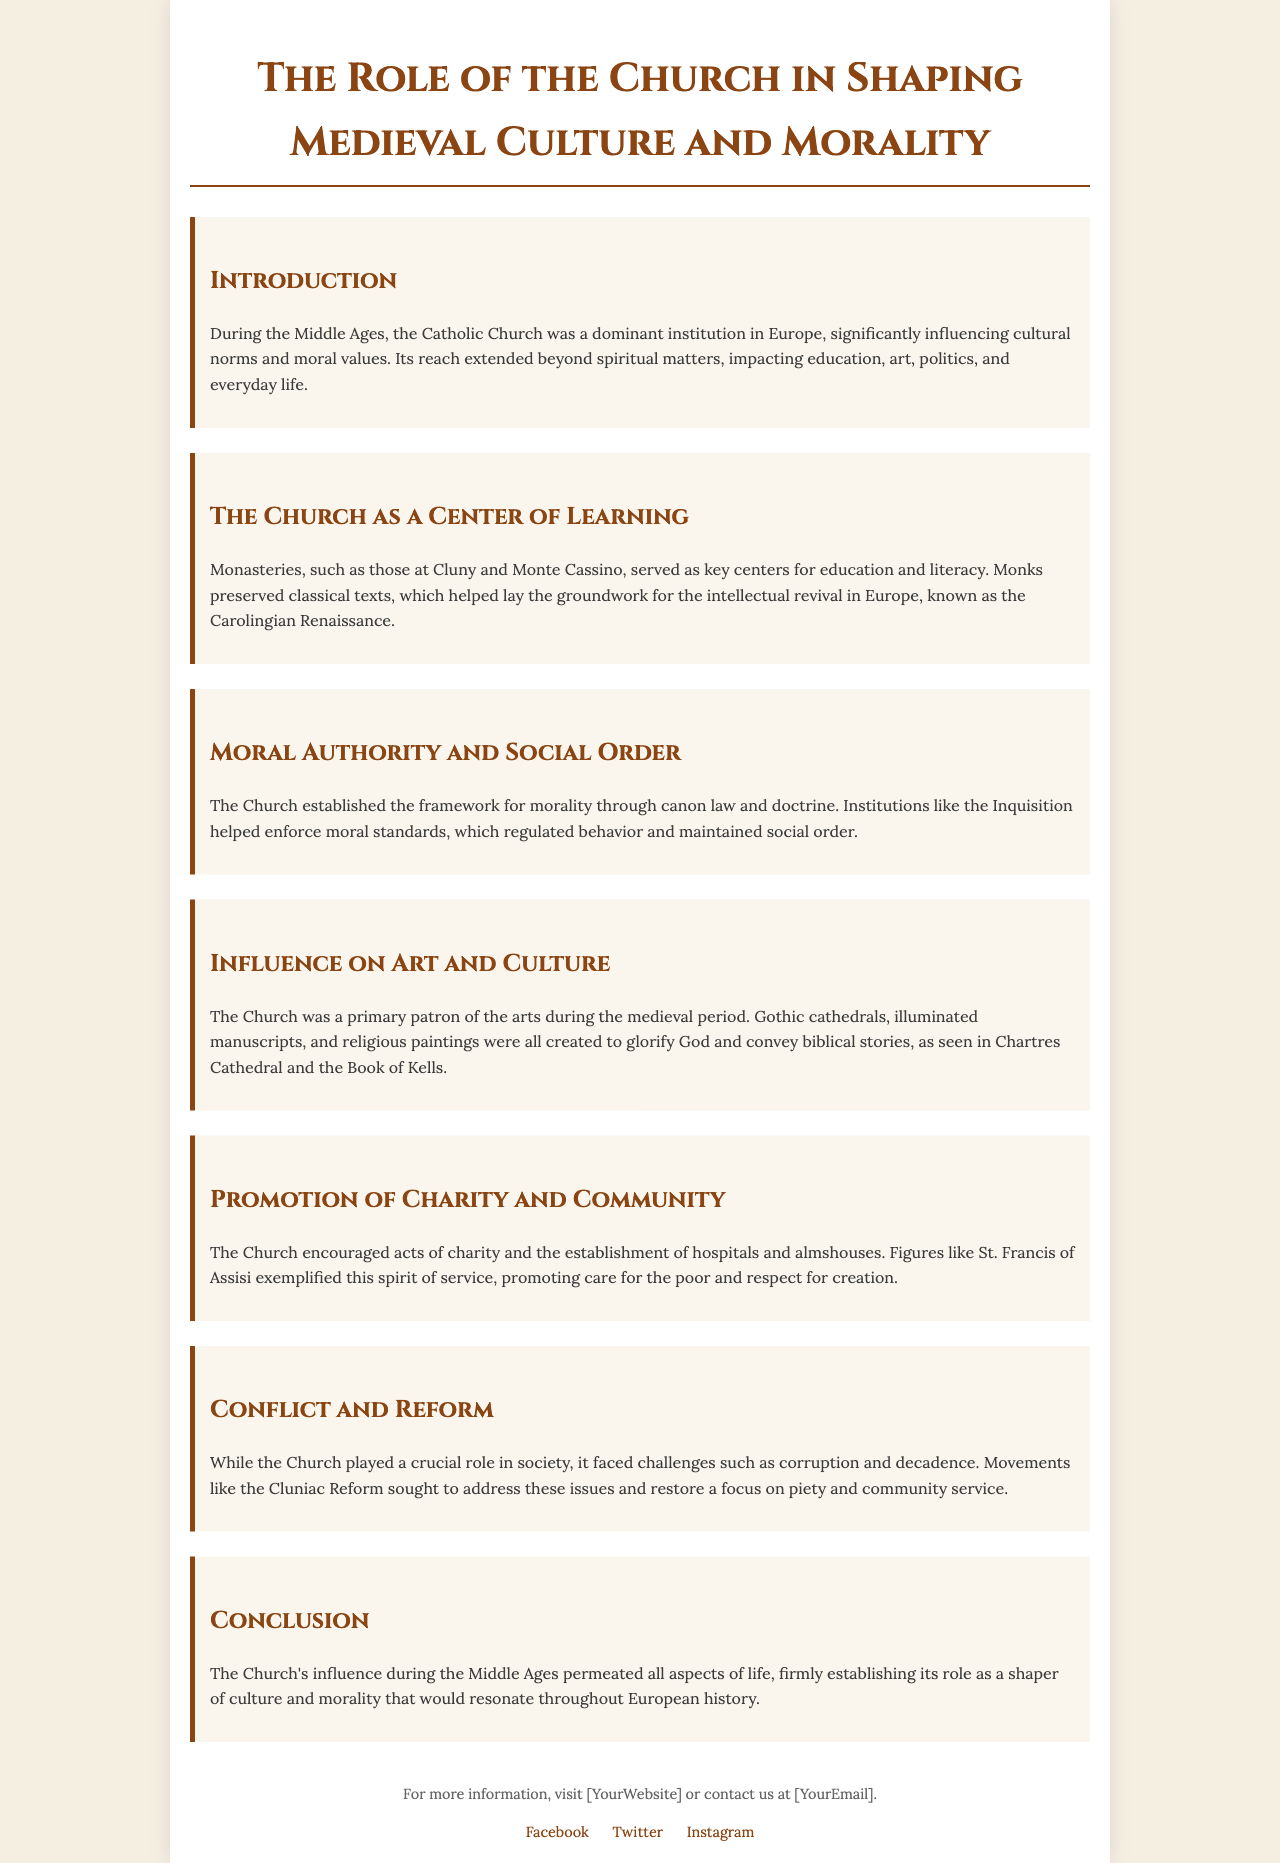What is the dominant institution in Europe during the Middle Ages? The document states that the Catholic Church was a dominant institution in Europe, influencing various aspects of society.
Answer: Catholic Church Which two monasteries are highlighted as key centers for education? The brochure mentions Cluny and Monte Cassino as significant centers for education and literacy during the Middle Ages.
Answer: Cluny and Monte Cassino What revival did the preservation of classical texts help lay the groundwork for? The text refers to the intellectual revival in Europe known as the Carolingian Renaissance, which was influenced by the preservation of texts.
Answer: Carolingian Renaissance What role did the Church play in enforcing moral standards? The document mentions that institutions like the Inquisition helped to regulate behavior and maintain social order by enforcing moral standards.
Answer: Inquisition Who is mentioned as exemplifying the spirit of service in the Church? The brochure refers to St. Francis of Assisi as a figure who promoted care for the poor and respect for creation.
Answer: St. Francis of Assisi What type of structures did the Church primarily patronize during the medieval period? The document indicates that the Church was a primary patron of the arts, creating Gothic cathedrals, illuminated manuscripts, and religious paintings.
Answer: Gothic cathedrals What movement sought to address issues of corruption and decadence in the Church? The text mentions the Cluniac Reform as a movement aimed at addressing corruption and restoring a focus on piety and community service.
Answer: Cluniac Reform What impact did the Church have on community services? The brochure states that the Church encouraged acts of charity and the establishment of hospitals and almshouses to support community welfare.
Answer: Charity and hospitals What is the main theme of the conclusion? The conclusion emphasizes the Church's pervasive influence on all aspects of life during the Middle Ages, establishing its role in shaping culture and morality.
Answer: Shaping culture and morality 